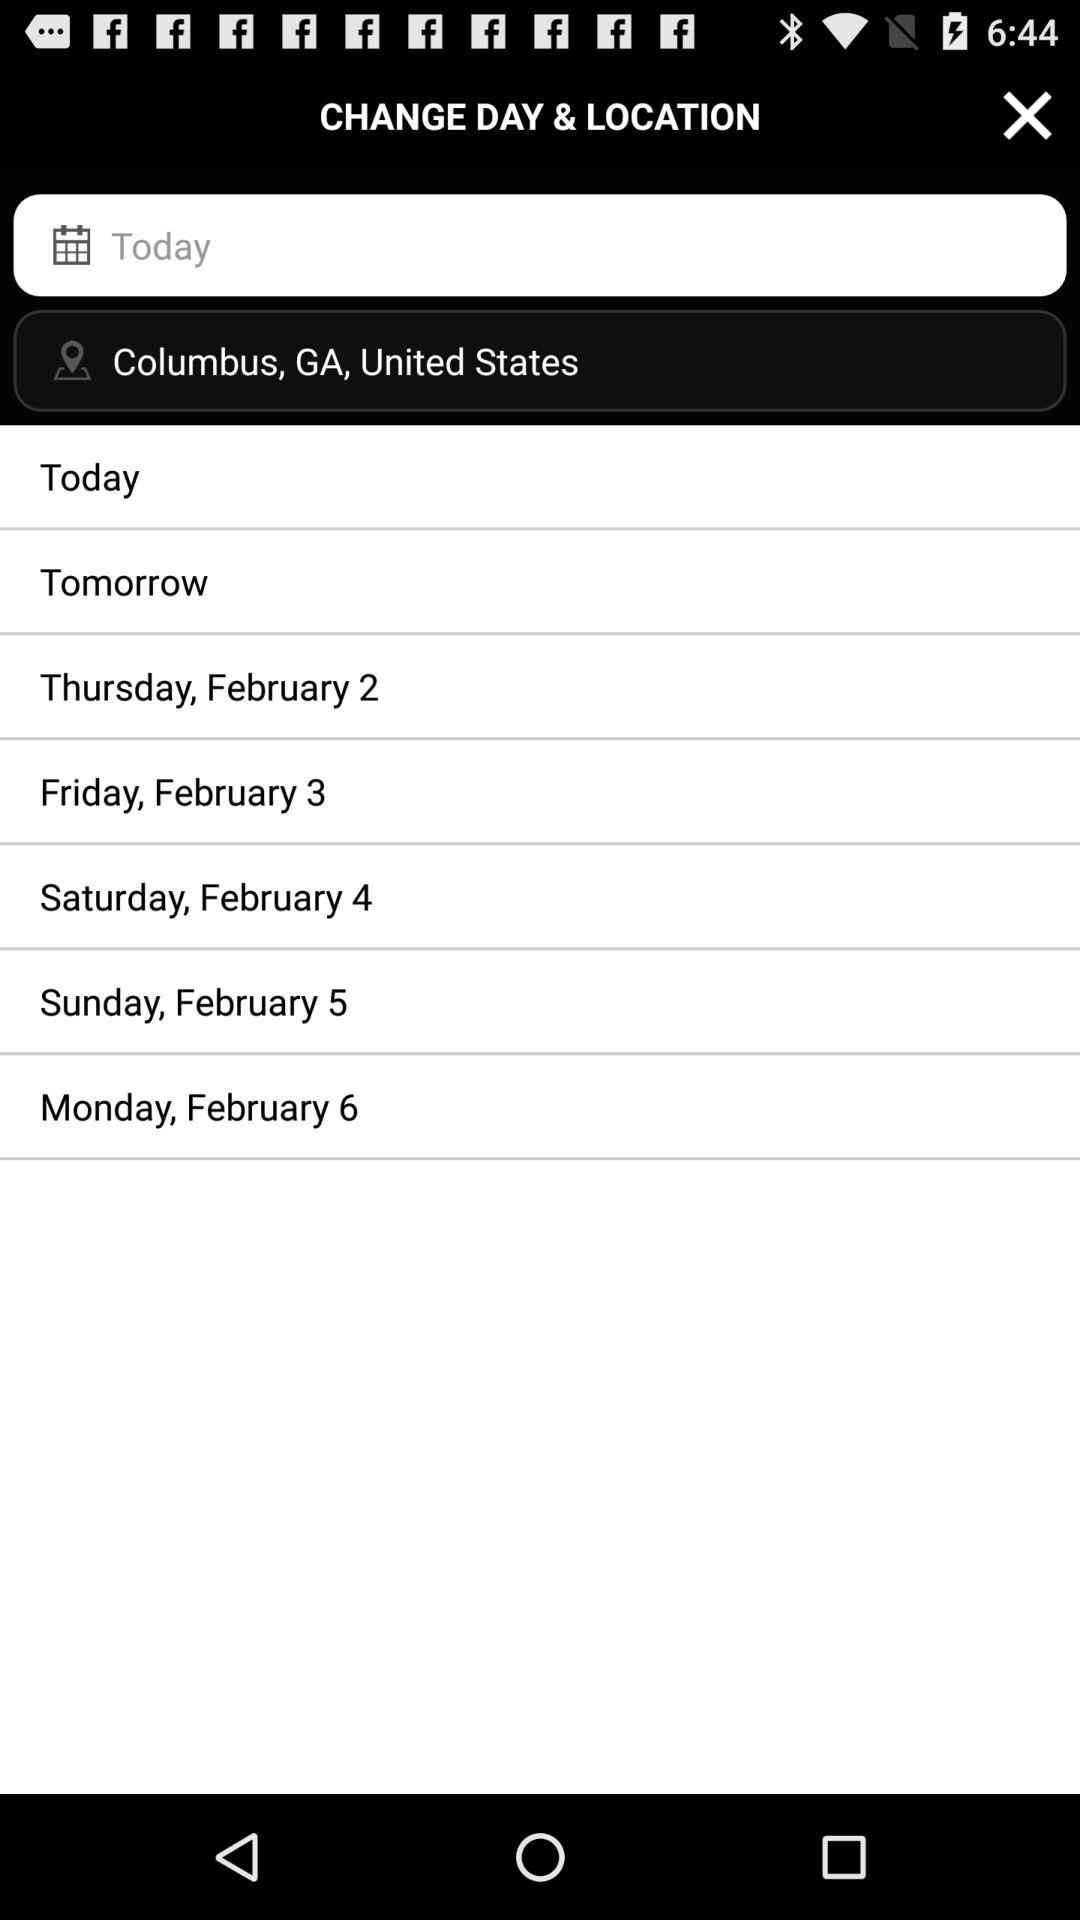What is the location? The location is Columbus, Georgia in the United States. 